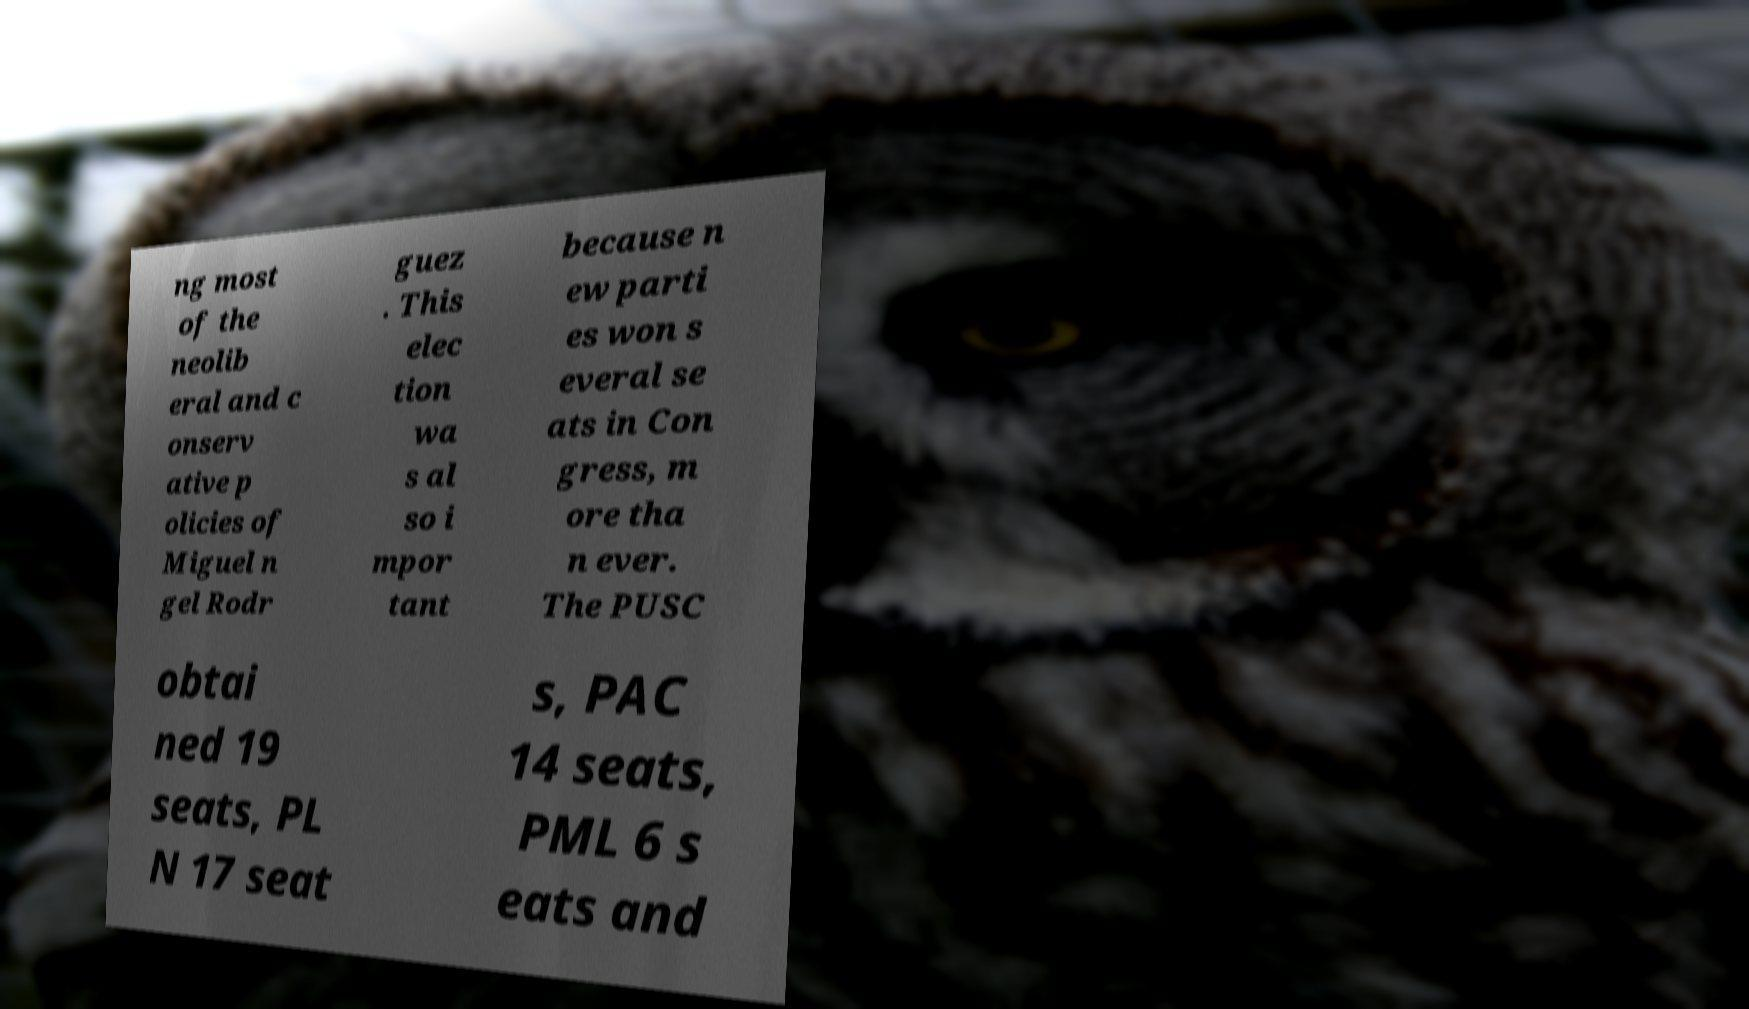There's text embedded in this image that I need extracted. Can you transcribe it verbatim? ng most of the neolib eral and c onserv ative p olicies of Miguel n gel Rodr guez . This elec tion wa s al so i mpor tant because n ew parti es won s everal se ats in Con gress, m ore tha n ever. The PUSC obtai ned 19 seats, PL N 17 seat s, PAC 14 seats, PML 6 s eats and 